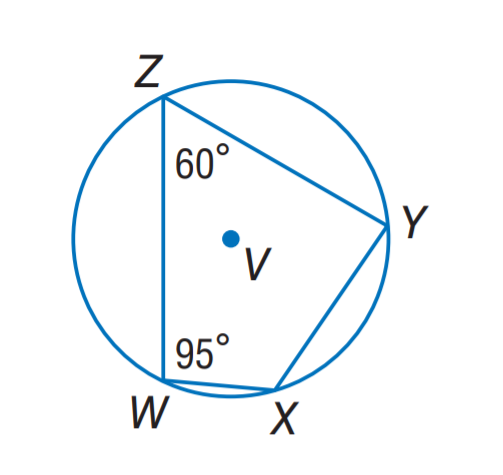Answer the mathemtical geometry problem and directly provide the correct option letter.
Question: Quadrilateral W X Y Z is inscribed in \odot V. Find m \angle Y.
Choices: A: 60 B: 85 C: 95 D: 120 B 